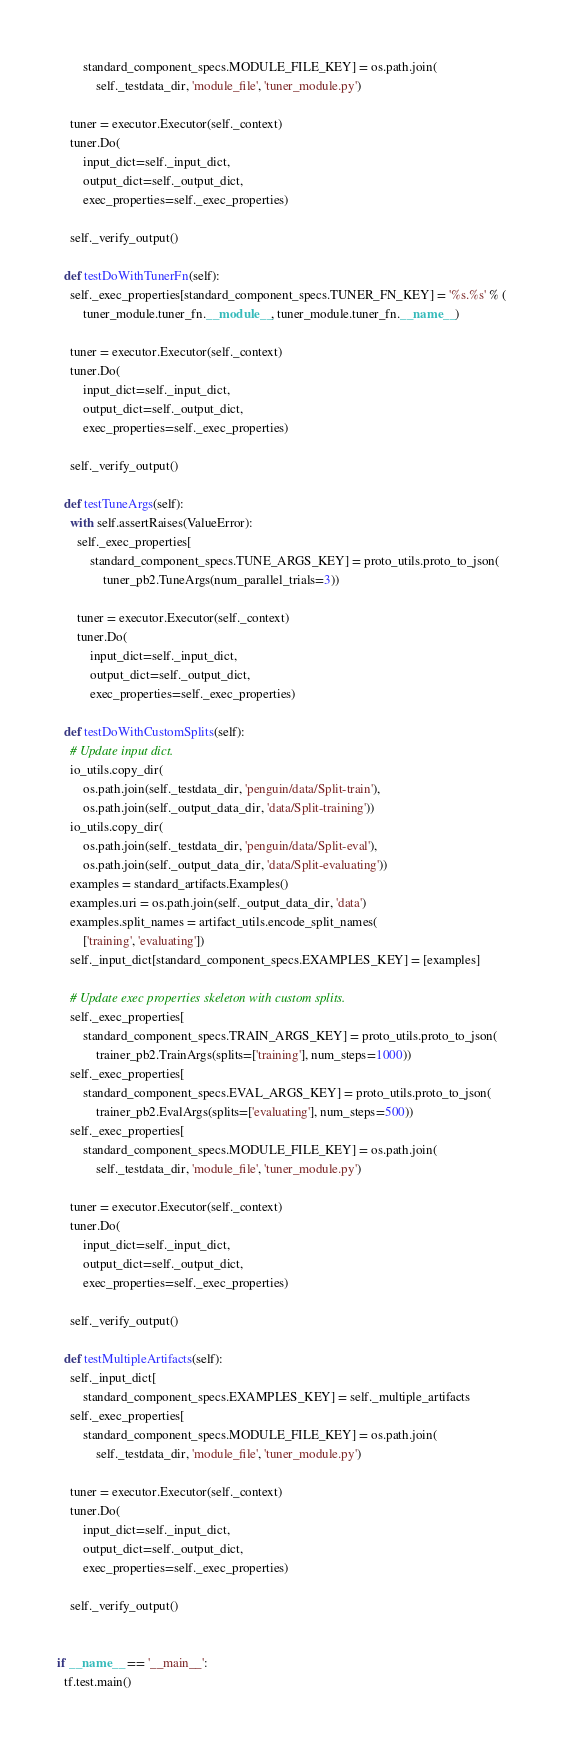Convert code to text. <code><loc_0><loc_0><loc_500><loc_500><_Python_>        standard_component_specs.MODULE_FILE_KEY] = os.path.join(
            self._testdata_dir, 'module_file', 'tuner_module.py')

    tuner = executor.Executor(self._context)
    tuner.Do(
        input_dict=self._input_dict,
        output_dict=self._output_dict,
        exec_properties=self._exec_properties)

    self._verify_output()

  def testDoWithTunerFn(self):
    self._exec_properties[standard_component_specs.TUNER_FN_KEY] = '%s.%s' % (
        tuner_module.tuner_fn.__module__, tuner_module.tuner_fn.__name__)

    tuner = executor.Executor(self._context)
    tuner.Do(
        input_dict=self._input_dict,
        output_dict=self._output_dict,
        exec_properties=self._exec_properties)

    self._verify_output()

  def testTuneArgs(self):
    with self.assertRaises(ValueError):
      self._exec_properties[
          standard_component_specs.TUNE_ARGS_KEY] = proto_utils.proto_to_json(
              tuner_pb2.TuneArgs(num_parallel_trials=3))

      tuner = executor.Executor(self._context)
      tuner.Do(
          input_dict=self._input_dict,
          output_dict=self._output_dict,
          exec_properties=self._exec_properties)

  def testDoWithCustomSplits(self):
    # Update input dict.
    io_utils.copy_dir(
        os.path.join(self._testdata_dir, 'penguin/data/Split-train'),
        os.path.join(self._output_data_dir, 'data/Split-training'))
    io_utils.copy_dir(
        os.path.join(self._testdata_dir, 'penguin/data/Split-eval'),
        os.path.join(self._output_data_dir, 'data/Split-evaluating'))
    examples = standard_artifacts.Examples()
    examples.uri = os.path.join(self._output_data_dir, 'data')
    examples.split_names = artifact_utils.encode_split_names(
        ['training', 'evaluating'])
    self._input_dict[standard_component_specs.EXAMPLES_KEY] = [examples]

    # Update exec properties skeleton with custom splits.
    self._exec_properties[
        standard_component_specs.TRAIN_ARGS_KEY] = proto_utils.proto_to_json(
            trainer_pb2.TrainArgs(splits=['training'], num_steps=1000))
    self._exec_properties[
        standard_component_specs.EVAL_ARGS_KEY] = proto_utils.proto_to_json(
            trainer_pb2.EvalArgs(splits=['evaluating'], num_steps=500))
    self._exec_properties[
        standard_component_specs.MODULE_FILE_KEY] = os.path.join(
            self._testdata_dir, 'module_file', 'tuner_module.py')

    tuner = executor.Executor(self._context)
    tuner.Do(
        input_dict=self._input_dict,
        output_dict=self._output_dict,
        exec_properties=self._exec_properties)

    self._verify_output()

  def testMultipleArtifacts(self):
    self._input_dict[
        standard_component_specs.EXAMPLES_KEY] = self._multiple_artifacts
    self._exec_properties[
        standard_component_specs.MODULE_FILE_KEY] = os.path.join(
            self._testdata_dir, 'module_file', 'tuner_module.py')

    tuner = executor.Executor(self._context)
    tuner.Do(
        input_dict=self._input_dict,
        output_dict=self._output_dict,
        exec_properties=self._exec_properties)

    self._verify_output()


if __name__ == '__main__':
  tf.test.main()
</code> 